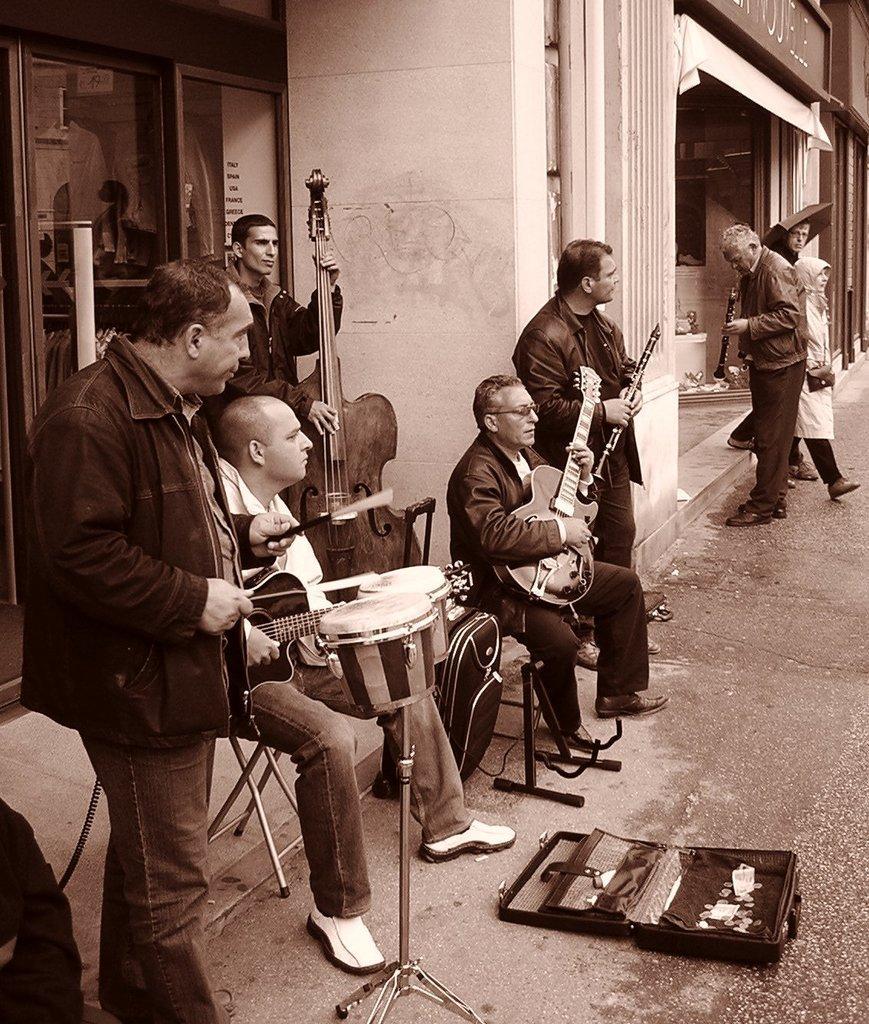Could you give a brief overview of what you see in this image? In the picture we can see five people are standing and two are sitting on the chairs. And one person is holding a guitar who is sitting and the other five members are holding musical instruments. In the background we can find a building, wall and on the floor we can find something. 